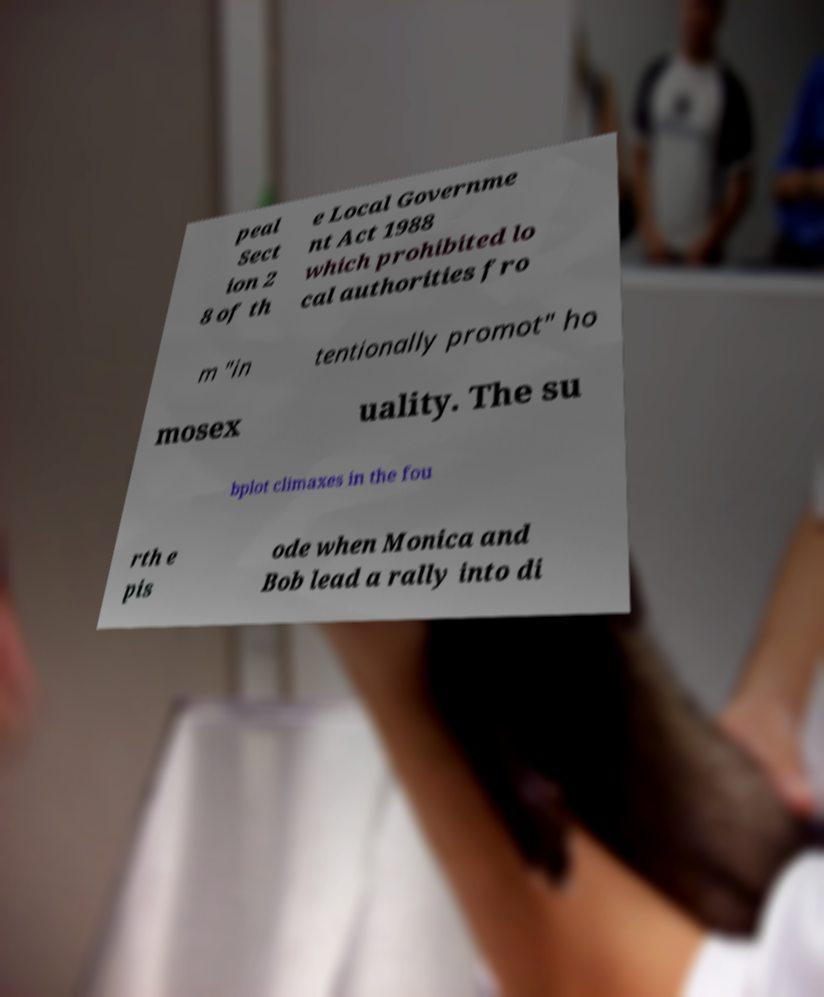Please identify and transcribe the text found in this image. peal Sect ion 2 8 of th e Local Governme nt Act 1988 which prohibited lo cal authorities fro m "in tentionally promot" ho mosex uality. The su bplot climaxes in the fou rth e pis ode when Monica and Bob lead a rally into di 